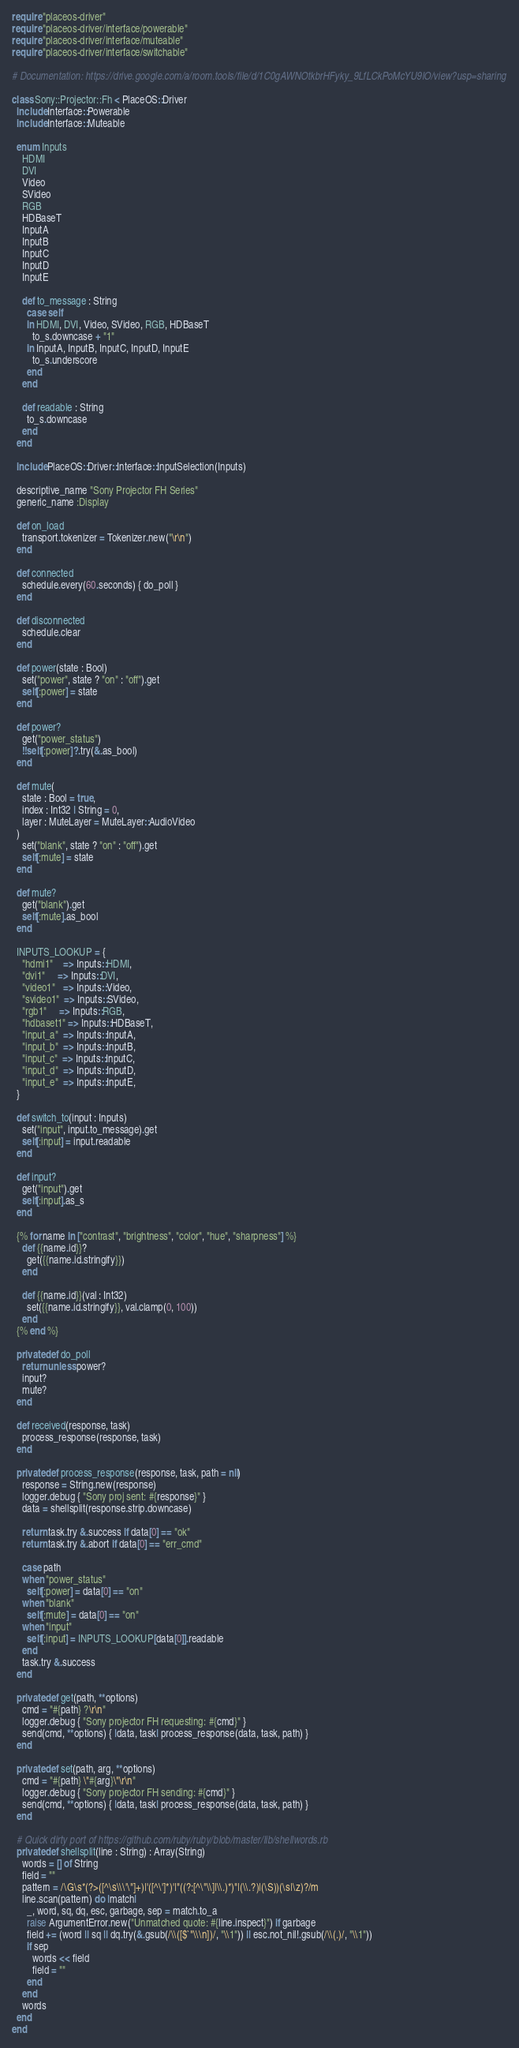Convert code to text. <code><loc_0><loc_0><loc_500><loc_500><_Crystal_>require "placeos-driver"
require "placeos-driver/interface/powerable"
require "placeos-driver/interface/muteable"
require "placeos-driver/interface/switchable"

# Documentation: https://drive.google.com/a/room.tools/file/d/1C0gAWNOtkbrHFyky_9LfLCkPoMcYU9lO/view?usp=sharing

class Sony::Projector::Fh < PlaceOS::Driver
  include Interface::Powerable
  include Interface::Muteable

  enum Inputs
    HDMI
    DVI
    Video
    SVideo
    RGB
    HDBaseT
    InputA
    InputB
    InputC
    InputD
    InputE

    def to_message : String
      case self
      in HDMI, DVI, Video, SVideo, RGB, HDBaseT
        to_s.downcase + "1"
      in InputA, InputB, InputC, InputD, InputE
        to_s.underscore
      end
    end

    def readable : String
      to_s.downcase
    end
  end

  include PlaceOS::Driver::Interface::InputSelection(Inputs)

  descriptive_name "Sony Projector FH Series"
  generic_name :Display

  def on_load
    transport.tokenizer = Tokenizer.new("\r\n")
  end

  def connected
    schedule.every(60.seconds) { do_poll }
  end

  def disconnected
    schedule.clear
  end

  def power(state : Bool)
    set("power", state ? "on" : "off").get
    self[:power] = state
  end

  def power?
    get("power_status")
    !!self[:power]?.try(&.as_bool)
  end

  def mute(
    state : Bool = true,
    index : Int32 | String = 0,
    layer : MuteLayer = MuteLayer::AudioVideo
  )
    set("blank", state ? "on" : "off").get
    self[:mute] = state
  end

  def mute?
    get("blank").get
    self[:mute].as_bool
  end

  INPUTS_LOOKUP = {
    "hdmi1"    => Inputs::HDMI,
    "dvi1"     => Inputs::DVI,
    "video1"   => Inputs::Video,
    "svideo1"  => Inputs::SVideo,
    "rgb1"     => Inputs::RGB,
    "hdbaset1" => Inputs::HDBaseT,
    "input_a"  => Inputs::InputA,
    "input_b"  => Inputs::InputB,
    "input_c"  => Inputs::InputC,
    "input_d"  => Inputs::InputD,
    "input_e"  => Inputs::InputE,
  }

  def switch_to(input : Inputs)
    set("input", input.to_message).get
    self[:input] = input.readable
  end

  def input?
    get("input").get
    self[:input].as_s
  end

  {% for name in ["contrast", "brightness", "color", "hue", "sharpness"] %}
    def {{name.id}}?
      get({{name.id.stringify}})
    end

    def {{name.id}}(val : Int32)
      set({{name.id.stringify}}, val.clamp(0, 100))
    end
  {% end %}

  private def do_poll
    return unless power?
    input?
    mute?
  end

  def received(response, task)
    process_response(response, task)
  end

  private def process_response(response, task, path = nil)
    response = String.new(response)
    logger.debug { "Sony proj sent: #{response}" }
    data = shellsplit(response.strip.downcase)

    return task.try &.success if data[0] == "ok"
    return task.try &.abort if data[0] == "err_cmd"

    case path
    when "power_status"
      self[:power] = data[0] == "on"
    when "blank"
      self[:mute] = data[0] == "on"
    when "input"
      self[:input] = INPUTS_LOOKUP[data[0]].readable
    end
    task.try &.success
  end

  private def get(path, **options)
    cmd = "#{path} ?\r\n"
    logger.debug { "Sony projector FH requesting: #{cmd}" }
    send(cmd, **options) { |data, task| process_response(data, task, path) }
  end

  private def set(path, arg, **options)
    cmd = "#{path} \"#{arg}\"\r\n"
    logger.debug { "Sony projector FH sending: #{cmd}" }
    send(cmd, **options) { |data, task| process_response(data, task, path) }
  end

  # Quick dirty port of https://github.com/ruby/ruby/blob/master/lib/shellwords.rb
  private def shellsplit(line : String) : Array(String)
    words = [] of String
    field = ""
    pattern = /\G\s*(?>([^\s\\\'\"]+)|'([^\']*)'|"((?:[^\"\\]|\\.)*)"|(\\.?)|(\S))(\s|\z)?/m
    line.scan(pattern) do |match|
      _, word, sq, dq, esc, garbage, sep = match.to_a
      raise ArgumentError.new("Unmatched quote: #{line.inspect}") if garbage
      field += (word || sq || dq.try(&.gsub(/\\([$`"\\\n])/, "\\1")) || esc.not_nil!.gsub(/\\(.)/, "\\1"))
      if sep
        words << field
        field = ""
      end
    end
    words
  end
end
</code> 